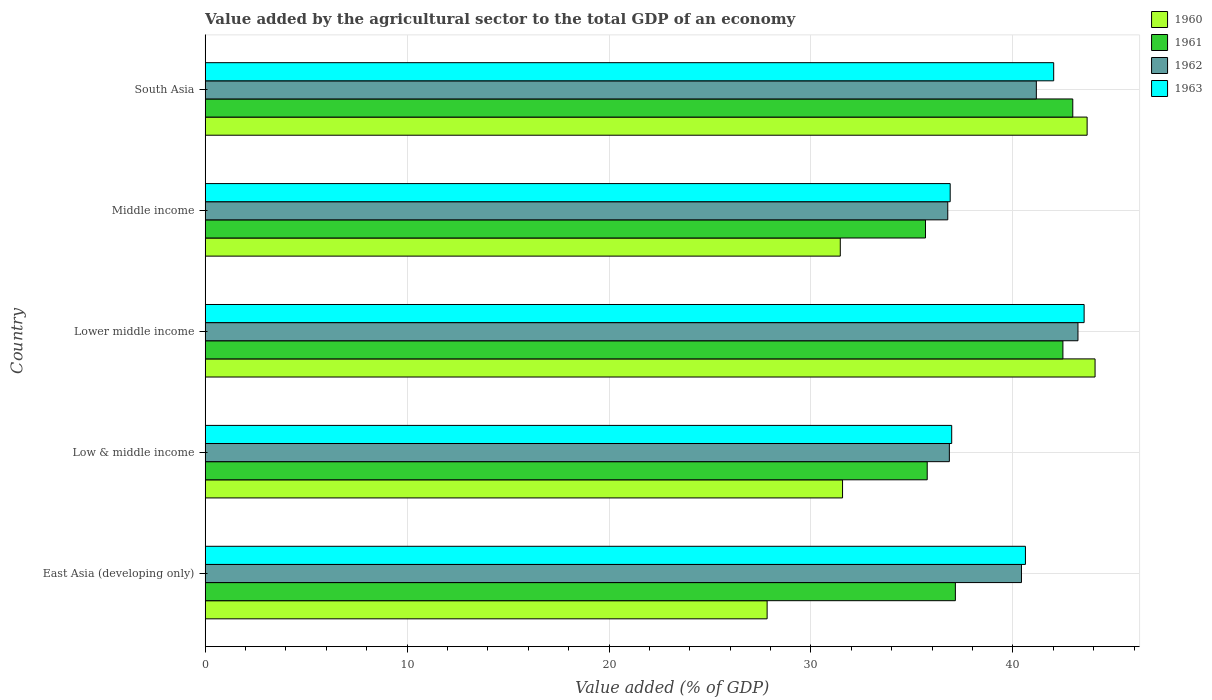How many different coloured bars are there?
Make the answer very short. 4. Are the number of bars per tick equal to the number of legend labels?
Your answer should be very brief. Yes. Are the number of bars on each tick of the Y-axis equal?
Your response must be concise. Yes. How many bars are there on the 1st tick from the top?
Offer a terse response. 4. How many bars are there on the 1st tick from the bottom?
Make the answer very short. 4. What is the label of the 3rd group of bars from the top?
Keep it short and to the point. Lower middle income. What is the value added by the agricultural sector to the total GDP in 1963 in Lower middle income?
Your response must be concise. 43.53. Across all countries, what is the maximum value added by the agricultural sector to the total GDP in 1962?
Offer a terse response. 43.22. Across all countries, what is the minimum value added by the agricultural sector to the total GDP in 1961?
Keep it short and to the point. 35.67. In which country was the value added by the agricultural sector to the total GDP in 1963 maximum?
Keep it short and to the point. Lower middle income. In which country was the value added by the agricultural sector to the total GDP in 1960 minimum?
Ensure brevity in your answer.  East Asia (developing only). What is the total value added by the agricultural sector to the total GDP in 1961 in the graph?
Your response must be concise. 194.02. What is the difference between the value added by the agricultural sector to the total GDP in 1963 in Low & middle income and that in Lower middle income?
Provide a short and direct response. -6.56. What is the difference between the value added by the agricultural sector to the total GDP in 1960 in Middle income and the value added by the agricultural sector to the total GDP in 1961 in Low & middle income?
Make the answer very short. -4.31. What is the average value added by the agricultural sector to the total GDP in 1960 per country?
Ensure brevity in your answer.  35.72. What is the difference between the value added by the agricultural sector to the total GDP in 1963 and value added by the agricultural sector to the total GDP in 1962 in Middle income?
Offer a very short reply. 0.12. In how many countries, is the value added by the agricultural sector to the total GDP in 1963 greater than 24 %?
Offer a very short reply. 5. What is the ratio of the value added by the agricultural sector to the total GDP in 1960 in East Asia (developing only) to that in South Asia?
Make the answer very short. 0.64. Is the difference between the value added by the agricultural sector to the total GDP in 1963 in East Asia (developing only) and Low & middle income greater than the difference between the value added by the agricultural sector to the total GDP in 1962 in East Asia (developing only) and Low & middle income?
Your answer should be very brief. Yes. What is the difference between the highest and the second highest value added by the agricultural sector to the total GDP in 1962?
Your answer should be very brief. 2.06. What is the difference between the highest and the lowest value added by the agricultural sector to the total GDP in 1962?
Your answer should be compact. 6.45. In how many countries, is the value added by the agricultural sector to the total GDP in 1962 greater than the average value added by the agricultural sector to the total GDP in 1962 taken over all countries?
Your answer should be compact. 3. Is the sum of the value added by the agricultural sector to the total GDP in 1960 in Low & middle income and South Asia greater than the maximum value added by the agricultural sector to the total GDP in 1963 across all countries?
Give a very brief answer. Yes. How many countries are there in the graph?
Offer a very short reply. 5. What is the difference between two consecutive major ticks on the X-axis?
Make the answer very short. 10. Are the values on the major ticks of X-axis written in scientific E-notation?
Provide a succinct answer. No. Does the graph contain any zero values?
Ensure brevity in your answer.  No. How are the legend labels stacked?
Offer a terse response. Vertical. What is the title of the graph?
Your response must be concise. Value added by the agricultural sector to the total GDP of an economy. What is the label or title of the X-axis?
Your answer should be compact. Value added (% of GDP). What is the label or title of the Y-axis?
Your answer should be compact. Country. What is the Value added (% of GDP) of 1960 in East Asia (developing only)?
Offer a very short reply. 27.83. What is the Value added (% of GDP) in 1961 in East Asia (developing only)?
Your answer should be very brief. 37.15. What is the Value added (% of GDP) of 1962 in East Asia (developing only)?
Ensure brevity in your answer.  40.42. What is the Value added (% of GDP) of 1963 in East Asia (developing only)?
Your answer should be very brief. 40.62. What is the Value added (% of GDP) of 1960 in Low & middle income?
Provide a succinct answer. 31.56. What is the Value added (% of GDP) of 1961 in Low & middle income?
Offer a terse response. 35.76. What is the Value added (% of GDP) in 1962 in Low & middle income?
Provide a short and direct response. 36.85. What is the Value added (% of GDP) in 1963 in Low & middle income?
Your answer should be compact. 36.97. What is the Value added (% of GDP) in 1960 in Lower middle income?
Your response must be concise. 44.07. What is the Value added (% of GDP) in 1961 in Lower middle income?
Ensure brevity in your answer.  42.48. What is the Value added (% of GDP) of 1962 in Lower middle income?
Your response must be concise. 43.22. What is the Value added (% of GDP) in 1963 in Lower middle income?
Keep it short and to the point. 43.53. What is the Value added (% of GDP) of 1960 in Middle income?
Your response must be concise. 31.45. What is the Value added (% of GDP) of 1961 in Middle income?
Give a very brief answer. 35.67. What is the Value added (% of GDP) of 1962 in Middle income?
Provide a succinct answer. 36.77. What is the Value added (% of GDP) of 1963 in Middle income?
Ensure brevity in your answer.  36.89. What is the Value added (% of GDP) of 1960 in South Asia?
Offer a terse response. 43.68. What is the Value added (% of GDP) of 1961 in South Asia?
Offer a terse response. 42.96. What is the Value added (% of GDP) of 1962 in South Asia?
Your answer should be very brief. 41.16. What is the Value added (% of GDP) in 1963 in South Asia?
Give a very brief answer. 42.02. Across all countries, what is the maximum Value added (% of GDP) in 1960?
Your answer should be compact. 44.07. Across all countries, what is the maximum Value added (% of GDP) of 1961?
Offer a very short reply. 42.96. Across all countries, what is the maximum Value added (% of GDP) of 1962?
Provide a succinct answer. 43.22. Across all countries, what is the maximum Value added (% of GDP) of 1963?
Provide a succinct answer. 43.53. Across all countries, what is the minimum Value added (% of GDP) in 1960?
Keep it short and to the point. 27.83. Across all countries, what is the minimum Value added (% of GDP) of 1961?
Ensure brevity in your answer.  35.67. Across all countries, what is the minimum Value added (% of GDP) in 1962?
Offer a very short reply. 36.77. Across all countries, what is the minimum Value added (% of GDP) of 1963?
Provide a short and direct response. 36.89. What is the total Value added (% of GDP) of 1960 in the graph?
Your answer should be compact. 178.59. What is the total Value added (% of GDP) in 1961 in the graph?
Ensure brevity in your answer.  194.02. What is the total Value added (% of GDP) of 1962 in the graph?
Provide a short and direct response. 198.43. What is the total Value added (% of GDP) in 1963 in the graph?
Provide a succinct answer. 200.03. What is the difference between the Value added (% of GDP) of 1960 in East Asia (developing only) and that in Low & middle income?
Your answer should be very brief. -3.74. What is the difference between the Value added (% of GDP) in 1961 in East Asia (developing only) and that in Low & middle income?
Make the answer very short. 1.39. What is the difference between the Value added (% of GDP) of 1962 in East Asia (developing only) and that in Low & middle income?
Keep it short and to the point. 3.57. What is the difference between the Value added (% of GDP) of 1963 in East Asia (developing only) and that in Low & middle income?
Your response must be concise. 3.65. What is the difference between the Value added (% of GDP) in 1960 in East Asia (developing only) and that in Lower middle income?
Your response must be concise. -16.24. What is the difference between the Value added (% of GDP) in 1961 in East Asia (developing only) and that in Lower middle income?
Provide a succinct answer. -5.33. What is the difference between the Value added (% of GDP) in 1962 in East Asia (developing only) and that in Lower middle income?
Your answer should be very brief. -2.8. What is the difference between the Value added (% of GDP) in 1963 in East Asia (developing only) and that in Lower middle income?
Your answer should be compact. -2.91. What is the difference between the Value added (% of GDP) of 1960 in East Asia (developing only) and that in Middle income?
Provide a short and direct response. -3.62. What is the difference between the Value added (% of GDP) of 1961 in East Asia (developing only) and that in Middle income?
Offer a terse response. 1.48. What is the difference between the Value added (% of GDP) of 1962 in East Asia (developing only) and that in Middle income?
Your answer should be very brief. 3.65. What is the difference between the Value added (% of GDP) in 1963 in East Asia (developing only) and that in Middle income?
Your answer should be very brief. 3.73. What is the difference between the Value added (% of GDP) of 1960 in East Asia (developing only) and that in South Asia?
Provide a succinct answer. -15.85. What is the difference between the Value added (% of GDP) of 1961 in East Asia (developing only) and that in South Asia?
Your answer should be very brief. -5.81. What is the difference between the Value added (% of GDP) of 1962 in East Asia (developing only) and that in South Asia?
Ensure brevity in your answer.  -0.74. What is the difference between the Value added (% of GDP) in 1963 in East Asia (developing only) and that in South Asia?
Keep it short and to the point. -1.4. What is the difference between the Value added (% of GDP) in 1960 in Low & middle income and that in Lower middle income?
Your response must be concise. -12.51. What is the difference between the Value added (% of GDP) of 1961 in Low & middle income and that in Lower middle income?
Give a very brief answer. -6.72. What is the difference between the Value added (% of GDP) of 1962 in Low & middle income and that in Lower middle income?
Keep it short and to the point. -6.37. What is the difference between the Value added (% of GDP) in 1963 in Low & middle income and that in Lower middle income?
Provide a short and direct response. -6.56. What is the difference between the Value added (% of GDP) in 1960 in Low & middle income and that in Middle income?
Your response must be concise. 0.11. What is the difference between the Value added (% of GDP) in 1961 in Low & middle income and that in Middle income?
Give a very brief answer. 0.09. What is the difference between the Value added (% of GDP) in 1962 in Low & middle income and that in Middle income?
Provide a succinct answer. 0.08. What is the difference between the Value added (% of GDP) in 1963 in Low & middle income and that in Middle income?
Your answer should be very brief. 0.07. What is the difference between the Value added (% of GDP) of 1960 in Low & middle income and that in South Asia?
Your answer should be very brief. -12.11. What is the difference between the Value added (% of GDP) in 1961 in Low & middle income and that in South Asia?
Keep it short and to the point. -7.21. What is the difference between the Value added (% of GDP) in 1962 in Low & middle income and that in South Asia?
Offer a terse response. -4.31. What is the difference between the Value added (% of GDP) of 1963 in Low & middle income and that in South Asia?
Offer a terse response. -5.05. What is the difference between the Value added (% of GDP) in 1960 in Lower middle income and that in Middle income?
Ensure brevity in your answer.  12.62. What is the difference between the Value added (% of GDP) of 1961 in Lower middle income and that in Middle income?
Offer a very short reply. 6.81. What is the difference between the Value added (% of GDP) in 1962 in Lower middle income and that in Middle income?
Make the answer very short. 6.45. What is the difference between the Value added (% of GDP) of 1963 in Lower middle income and that in Middle income?
Make the answer very short. 6.63. What is the difference between the Value added (% of GDP) of 1960 in Lower middle income and that in South Asia?
Your answer should be compact. 0.39. What is the difference between the Value added (% of GDP) of 1961 in Lower middle income and that in South Asia?
Your answer should be compact. -0.49. What is the difference between the Value added (% of GDP) in 1962 in Lower middle income and that in South Asia?
Keep it short and to the point. 2.06. What is the difference between the Value added (% of GDP) of 1963 in Lower middle income and that in South Asia?
Your answer should be very brief. 1.51. What is the difference between the Value added (% of GDP) of 1960 in Middle income and that in South Asia?
Your response must be concise. -12.22. What is the difference between the Value added (% of GDP) of 1961 in Middle income and that in South Asia?
Keep it short and to the point. -7.29. What is the difference between the Value added (% of GDP) of 1962 in Middle income and that in South Asia?
Your answer should be compact. -4.39. What is the difference between the Value added (% of GDP) in 1963 in Middle income and that in South Asia?
Offer a terse response. -5.13. What is the difference between the Value added (% of GDP) in 1960 in East Asia (developing only) and the Value added (% of GDP) in 1961 in Low & middle income?
Provide a short and direct response. -7.93. What is the difference between the Value added (% of GDP) in 1960 in East Asia (developing only) and the Value added (% of GDP) in 1962 in Low & middle income?
Offer a very short reply. -9.02. What is the difference between the Value added (% of GDP) in 1960 in East Asia (developing only) and the Value added (% of GDP) in 1963 in Low & middle income?
Give a very brief answer. -9.14. What is the difference between the Value added (% of GDP) of 1961 in East Asia (developing only) and the Value added (% of GDP) of 1962 in Low & middle income?
Your answer should be very brief. 0.3. What is the difference between the Value added (% of GDP) of 1961 in East Asia (developing only) and the Value added (% of GDP) of 1963 in Low & middle income?
Make the answer very short. 0.18. What is the difference between the Value added (% of GDP) of 1962 in East Asia (developing only) and the Value added (% of GDP) of 1963 in Low & middle income?
Give a very brief answer. 3.46. What is the difference between the Value added (% of GDP) of 1960 in East Asia (developing only) and the Value added (% of GDP) of 1961 in Lower middle income?
Provide a succinct answer. -14.65. What is the difference between the Value added (% of GDP) of 1960 in East Asia (developing only) and the Value added (% of GDP) of 1962 in Lower middle income?
Ensure brevity in your answer.  -15.39. What is the difference between the Value added (% of GDP) in 1960 in East Asia (developing only) and the Value added (% of GDP) in 1963 in Lower middle income?
Give a very brief answer. -15.7. What is the difference between the Value added (% of GDP) in 1961 in East Asia (developing only) and the Value added (% of GDP) in 1962 in Lower middle income?
Make the answer very short. -6.07. What is the difference between the Value added (% of GDP) of 1961 in East Asia (developing only) and the Value added (% of GDP) of 1963 in Lower middle income?
Offer a terse response. -6.38. What is the difference between the Value added (% of GDP) of 1962 in East Asia (developing only) and the Value added (% of GDP) of 1963 in Lower middle income?
Make the answer very short. -3.1. What is the difference between the Value added (% of GDP) in 1960 in East Asia (developing only) and the Value added (% of GDP) in 1961 in Middle income?
Provide a succinct answer. -7.84. What is the difference between the Value added (% of GDP) in 1960 in East Asia (developing only) and the Value added (% of GDP) in 1962 in Middle income?
Provide a short and direct response. -8.95. What is the difference between the Value added (% of GDP) in 1960 in East Asia (developing only) and the Value added (% of GDP) in 1963 in Middle income?
Provide a succinct answer. -9.07. What is the difference between the Value added (% of GDP) in 1961 in East Asia (developing only) and the Value added (% of GDP) in 1962 in Middle income?
Your answer should be compact. 0.38. What is the difference between the Value added (% of GDP) in 1961 in East Asia (developing only) and the Value added (% of GDP) in 1963 in Middle income?
Provide a succinct answer. 0.26. What is the difference between the Value added (% of GDP) in 1962 in East Asia (developing only) and the Value added (% of GDP) in 1963 in Middle income?
Make the answer very short. 3.53. What is the difference between the Value added (% of GDP) of 1960 in East Asia (developing only) and the Value added (% of GDP) of 1961 in South Asia?
Give a very brief answer. -15.14. What is the difference between the Value added (% of GDP) of 1960 in East Asia (developing only) and the Value added (% of GDP) of 1962 in South Asia?
Offer a very short reply. -13.33. What is the difference between the Value added (% of GDP) in 1960 in East Asia (developing only) and the Value added (% of GDP) in 1963 in South Asia?
Make the answer very short. -14.19. What is the difference between the Value added (% of GDP) in 1961 in East Asia (developing only) and the Value added (% of GDP) in 1962 in South Asia?
Provide a succinct answer. -4.01. What is the difference between the Value added (% of GDP) of 1961 in East Asia (developing only) and the Value added (% of GDP) of 1963 in South Asia?
Ensure brevity in your answer.  -4.87. What is the difference between the Value added (% of GDP) of 1962 in East Asia (developing only) and the Value added (% of GDP) of 1963 in South Asia?
Keep it short and to the point. -1.6. What is the difference between the Value added (% of GDP) of 1960 in Low & middle income and the Value added (% of GDP) of 1961 in Lower middle income?
Your answer should be very brief. -10.91. What is the difference between the Value added (% of GDP) of 1960 in Low & middle income and the Value added (% of GDP) of 1962 in Lower middle income?
Make the answer very short. -11.66. What is the difference between the Value added (% of GDP) of 1960 in Low & middle income and the Value added (% of GDP) of 1963 in Lower middle income?
Your answer should be compact. -11.96. What is the difference between the Value added (% of GDP) of 1961 in Low & middle income and the Value added (% of GDP) of 1962 in Lower middle income?
Provide a short and direct response. -7.47. What is the difference between the Value added (% of GDP) in 1961 in Low & middle income and the Value added (% of GDP) in 1963 in Lower middle income?
Your response must be concise. -7.77. What is the difference between the Value added (% of GDP) in 1962 in Low & middle income and the Value added (% of GDP) in 1963 in Lower middle income?
Ensure brevity in your answer.  -6.67. What is the difference between the Value added (% of GDP) in 1960 in Low & middle income and the Value added (% of GDP) in 1961 in Middle income?
Provide a succinct answer. -4.11. What is the difference between the Value added (% of GDP) in 1960 in Low & middle income and the Value added (% of GDP) in 1962 in Middle income?
Your response must be concise. -5.21. What is the difference between the Value added (% of GDP) of 1960 in Low & middle income and the Value added (% of GDP) of 1963 in Middle income?
Offer a terse response. -5.33. What is the difference between the Value added (% of GDP) of 1961 in Low & middle income and the Value added (% of GDP) of 1962 in Middle income?
Offer a very short reply. -1.02. What is the difference between the Value added (% of GDP) in 1961 in Low & middle income and the Value added (% of GDP) in 1963 in Middle income?
Keep it short and to the point. -1.14. What is the difference between the Value added (% of GDP) of 1962 in Low & middle income and the Value added (% of GDP) of 1963 in Middle income?
Your answer should be very brief. -0.04. What is the difference between the Value added (% of GDP) of 1960 in Low & middle income and the Value added (% of GDP) of 1961 in South Asia?
Provide a short and direct response. -11.4. What is the difference between the Value added (% of GDP) of 1960 in Low & middle income and the Value added (% of GDP) of 1962 in South Asia?
Your answer should be very brief. -9.6. What is the difference between the Value added (% of GDP) of 1960 in Low & middle income and the Value added (% of GDP) of 1963 in South Asia?
Provide a short and direct response. -10.46. What is the difference between the Value added (% of GDP) in 1961 in Low & middle income and the Value added (% of GDP) in 1962 in South Asia?
Offer a very short reply. -5.4. What is the difference between the Value added (% of GDP) of 1961 in Low & middle income and the Value added (% of GDP) of 1963 in South Asia?
Offer a very short reply. -6.26. What is the difference between the Value added (% of GDP) of 1962 in Low & middle income and the Value added (% of GDP) of 1963 in South Asia?
Offer a terse response. -5.17. What is the difference between the Value added (% of GDP) in 1960 in Lower middle income and the Value added (% of GDP) in 1961 in Middle income?
Offer a very short reply. 8.4. What is the difference between the Value added (% of GDP) of 1960 in Lower middle income and the Value added (% of GDP) of 1962 in Middle income?
Ensure brevity in your answer.  7.29. What is the difference between the Value added (% of GDP) in 1960 in Lower middle income and the Value added (% of GDP) in 1963 in Middle income?
Your answer should be very brief. 7.17. What is the difference between the Value added (% of GDP) in 1961 in Lower middle income and the Value added (% of GDP) in 1962 in Middle income?
Provide a succinct answer. 5.7. What is the difference between the Value added (% of GDP) of 1961 in Lower middle income and the Value added (% of GDP) of 1963 in Middle income?
Offer a very short reply. 5.58. What is the difference between the Value added (% of GDP) of 1962 in Lower middle income and the Value added (% of GDP) of 1963 in Middle income?
Give a very brief answer. 6.33. What is the difference between the Value added (% of GDP) in 1960 in Lower middle income and the Value added (% of GDP) in 1961 in South Asia?
Your response must be concise. 1.1. What is the difference between the Value added (% of GDP) of 1960 in Lower middle income and the Value added (% of GDP) of 1962 in South Asia?
Your response must be concise. 2.91. What is the difference between the Value added (% of GDP) of 1960 in Lower middle income and the Value added (% of GDP) of 1963 in South Asia?
Your answer should be compact. 2.05. What is the difference between the Value added (% of GDP) of 1961 in Lower middle income and the Value added (% of GDP) of 1962 in South Asia?
Keep it short and to the point. 1.32. What is the difference between the Value added (% of GDP) of 1961 in Lower middle income and the Value added (% of GDP) of 1963 in South Asia?
Offer a very short reply. 0.46. What is the difference between the Value added (% of GDP) in 1962 in Lower middle income and the Value added (% of GDP) in 1963 in South Asia?
Your response must be concise. 1.2. What is the difference between the Value added (% of GDP) of 1960 in Middle income and the Value added (% of GDP) of 1961 in South Asia?
Your answer should be very brief. -11.51. What is the difference between the Value added (% of GDP) in 1960 in Middle income and the Value added (% of GDP) in 1962 in South Asia?
Give a very brief answer. -9.71. What is the difference between the Value added (% of GDP) of 1960 in Middle income and the Value added (% of GDP) of 1963 in South Asia?
Offer a terse response. -10.57. What is the difference between the Value added (% of GDP) of 1961 in Middle income and the Value added (% of GDP) of 1962 in South Asia?
Your answer should be very brief. -5.49. What is the difference between the Value added (% of GDP) in 1961 in Middle income and the Value added (% of GDP) in 1963 in South Asia?
Your response must be concise. -6.35. What is the difference between the Value added (% of GDP) in 1962 in Middle income and the Value added (% of GDP) in 1963 in South Asia?
Give a very brief answer. -5.25. What is the average Value added (% of GDP) in 1960 per country?
Your answer should be compact. 35.72. What is the average Value added (% of GDP) in 1961 per country?
Offer a very short reply. 38.8. What is the average Value added (% of GDP) in 1962 per country?
Offer a terse response. 39.69. What is the average Value added (% of GDP) in 1963 per country?
Give a very brief answer. 40.01. What is the difference between the Value added (% of GDP) of 1960 and Value added (% of GDP) of 1961 in East Asia (developing only)?
Your response must be concise. -9.32. What is the difference between the Value added (% of GDP) of 1960 and Value added (% of GDP) of 1962 in East Asia (developing only)?
Give a very brief answer. -12.6. What is the difference between the Value added (% of GDP) in 1960 and Value added (% of GDP) in 1963 in East Asia (developing only)?
Provide a succinct answer. -12.79. What is the difference between the Value added (% of GDP) in 1961 and Value added (% of GDP) in 1962 in East Asia (developing only)?
Your answer should be compact. -3.27. What is the difference between the Value added (% of GDP) in 1961 and Value added (% of GDP) in 1963 in East Asia (developing only)?
Offer a terse response. -3.47. What is the difference between the Value added (% of GDP) in 1962 and Value added (% of GDP) in 1963 in East Asia (developing only)?
Your response must be concise. -0.2. What is the difference between the Value added (% of GDP) of 1960 and Value added (% of GDP) of 1961 in Low & middle income?
Ensure brevity in your answer.  -4.19. What is the difference between the Value added (% of GDP) in 1960 and Value added (% of GDP) in 1962 in Low & middle income?
Give a very brief answer. -5.29. What is the difference between the Value added (% of GDP) in 1960 and Value added (% of GDP) in 1963 in Low & middle income?
Your response must be concise. -5.41. What is the difference between the Value added (% of GDP) in 1961 and Value added (% of GDP) in 1962 in Low & middle income?
Give a very brief answer. -1.1. What is the difference between the Value added (% of GDP) in 1961 and Value added (% of GDP) in 1963 in Low & middle income?
Provide a succinct answer. -1.21. What is the difference between the Value added (% of GDP) in 1962 and Value added (% of GDP) in 1963 in Low & middle income?
Give a very brief answer. -0.12. What is the difference between the Value added (% of GDP) in 1960 and Value added (% of GDP) in 1961 in Lower middle income?
Ensure brevity in your answer.  1.59. What is the difference between the Value added (% of GDP) of 1960 and Value added (% of GDP) of 1962 in Lower middle income?
Your response must be concise. 0.85. What is the difference between the Value added (% of GDP) in 1960 and Value added (% of GDP) in 1963 in Lower middle income?
Make the answer very short. 0.54. What is the difference between the Value added (% of GDP) in 1961 and Value added (% of GDP) in 1962 in Lower middle income?
Give a very brief answer. -0.75. What is the difference between the Value added (% of GDP) of 1961 and Value added (% of GDP) of 1963 in Lower middle income?
Ensure brevity in your answer.  -1.05. What is the difference between the Value added (% of GDP) in 1962 and Value added (% of GDP) in 1963 in Lower middle income?
Keep it short and to the point. -0.3. What is the difference between the Value added (% of GDP) of 1960 and Value added (% of GDP) of 1961 in Middle income?
Your answer should be compact. -4.22. What is the difference between the Value added (% of GDP) of 1960 and Value added (% of GDP) of 1962 in Middle income?
Provide a succinct answer. -5.32. What is the difference between the Value added (% of GDP) of 1960 and Value added (% of GDP) of 1963 in Middle income?
Provide a short and direct response. -5.44. What is the difference between the Value added (% of GDP) in 1961 and Value added (% of GDP) in 1962 in Middle income?
Ensure brevity in your answer.  -1.1. What is the difference between the Value added (% of GDP) in 1961 and Value added (% of GDP) in 1963 in Middle income?
Offer a terse response. -1.22. What is the difference between the Value added (% of GDP) in 1962 and Value added (% of GDP) in 1963 in Middle income?
Keep it short and to the point. -0.12. What is the difference between the Value added (% of GDP) of 1960 and Value added (% of GDP) of 1961 in South Asia?
Keep it short and to the point. 0.71. What is the difference between the Value added (% of GDP) in 1960 and Value added (% of GDP) in 1962 in South Asia?
Make the answer very short. 2.52. What is the difference between the Value added (% of GDP) in 1960 and Value added (% of GDP) in 1963 in South Asia?
Keep it short and to the point. 1.66. What is the difference between the Value added (% of GDP) in 1961 and Value added (% of GDP) in 1962 in South Asia?
Make the answer very short. 1.8. What is the difference between the Value added (% of GDP) in 1961 and Value added (% of GDP) in 1963 in South Asia?
Keep it short and to the point. 0.95. What is the difference between the Value added (% of GDP) of 1962 and Value added (% of GDP) of 1963 in South Asia?
Keep it short and to the point. -0.86. What is the ratio of the Value added (% of GDP) in 1960 in East Asia (developing only) to that in Low & middle income?
Provide a short and direct response. 0.88. What is the ratio of the Value added (% of GDP) in 1961 in East Asia (developing only) to that in Low & middle income?
Keep it short and to the point. 1.04. What is the ratio of the Value added (% of GDP) in 1962 in East Asia (developing only) to that in Low & middle income?
Give a very brief answer. 1.1. What is the ratio of the Value added (% of GDP) of 1963 in East Asia (developing only) to that in Low & middle income?
Your response must be concise. 1.1. What is the ratio of the Value added (% of GDP) in 1960 in East Asia (developing only) to that in Lower middle income?
Offer a very short reply. 0.63. What is the ratio of the Value added (% of GDP) in 1961 in East Asia (developing only) to that in Lower middle income?
Your answer should be very brief. 0.87. What is the ratio of the Value added (% of GDP) of 1962 in East Asia (developing only) to that in Lower middle income?
Provide a succinct answer. 0.94. What is the ratio of the Value added (% of GDP) in 1963 in East Asia (developing only) to that in Lower middle income?
Your answer should be very brief. 0.93. What is the ratio of the Value added (% of GDP) in 1960 in East Asia (developing only) to that in Middle income?
Provide a short and direct response. 0.88. What is the ratio of the Value added (% of GDP) of 1961 in East Asia (developing only) to that in Middle income?
Offer a terse response. 1.04. What is the ratio of the Value added (% of GDP) of 1962 in East Asia (developing only) to that in Middle income?
Provide a succinct answer. 1.1. What is the ratio of the Value added (% of GDP) in 1963 in East Asia (developing only) to that in Middle income?
Keep it short and to the point. 1.1. What is the ratio of the Value added (% of GDP) in 1960 in East Asia (developing only) to that in South Asia?
Make the answer very short. 0.64. What is the ratio of the Value added (% of GDP) in 1961 in East Asia (developing only) to that in South Asia?
Your response must be concise. 0.86. What is the ratio of the Value added (% of GDP) of 1962 in East Asia (developing only) to that in South Asia?
Give a very brief answer. 0.98. What is the ratio of the Value added (% of GDP) of 1963 in East Asia (developing only) to that in South Asia?
Offer a very short reply. 0.97. What is the ratio of the Value added (% of GDP) in 1960 in Low & middle income to that in Lower middle income?
Offer a terse response. 0.72. What is the ratio of the Value added (% of GDP) of 1961 in Low & middle income to that in Lower middle income?
Your answer should be very brief. 0.84. What is the ratio of the Value added (% of GDP) of 1962 in Low & middle income to that in Lower middle income?
Give a very brief answer. 0.85. What is the ratio of the Value added (% of GDP) in 1963 in Low & middle income to that in Lower middle income?
Keep it short and to the point. 0.85. What is the ratio of the Value added (% of GDP) of 1960 in Low & middle income to that in Middle income?
Ensure brevity in your answer.  1. What is the ratio of the Value added (% of GDP) in 1961 in Low & middle income to that in Middle income?
Offer a very short reply. 1. What is the ratio of the Value added (% of GDP) in 1960 in Low & middle income to that in South Asia?
Give a very brief answer. 0.72. What is the ratio of the Value added (% of GDP) of 1961 in Low & middle income to that in South Asia?
Keep it short and to the point. 0.83. What is the ratio of the Value added (% of GDP) in 1962 in Low & middle income to that in South Asia?
Offer a very short reply. 0.9. What is the ratio of the Value added (% of GDP) of 1963 in Low & middle income to that in South Asia?
Give a very brief answer. 0.88. What is the ratio of the Value added (% of GDP) in 1960 in Lower middle income to that in Middle income?
Your answer should be very brief. 1.4. What is the ratio of the Value added (% of GDP) in 1961 in Lower middle income to that in Middle income?
Offer a terse response. 1.19. What is the ratio of the Value added (% of GDP) of 1962 in Lower middle income to that in Middle income?
Give a very brief answer. 1.18. What is the ratio of the Value added (% of GDP) of 1963 in Lower middle income to that in Middle income?
Provide a succinct answer. 1.18. What is the ratio of the Value added (% of GDP) of 1960 in Lower middle income to that in South Asia?
Provide a succinct answer. 1.01. What is the ratio of the Value added (% of GDP) in 1962 in Lower middle income to that in South Asia?
Your answer should be very brief. 1.05. What is the ratio of the Value added (% of GDP) of 1963 in Lower middle income to that in South Asia?
Provide a short and direct response. 1.04. What is the ratio of the Value added (% of GDP) in 1960 in Middle income to that in South Asia?
Provide a short and direct response. 0.72. What is the ratio of the Value added (% of GDP) of 1961 in Middle income to that in South Asia?
Your answer should be very brief. 0.83. What is the ratio of the Value added (% of GDP) in 1962 in Middle income to that in South Asia?
Make the answer very short. 0.89. What is the ratio of the Value added (% of GDP) of 1963 in Middle income to that in South Asia?
Keep it short and to the point. 0.88. What is the difference between the highest and the second highest Value added (% of GDP) in 1960?
Your response must be concise. 0.39. What is the difference between the highest and the second highest Value added (% of GDP) in 1961?
Provide a short and direct response. 0.49. What is the difference between the highest and the second highest Value added (% of GDP) in 1962?
Offer a very short reply. 2.06. What is the difference between the highest and the second highest Value added (% of GDP) in 1963?
Offer a terse response. 1.51. What is the difference between the highest and the lowest Value added (% of GDP) of 1960?
Provide a succinct answer. 16.24. What is the difference between the highest and the lowest Value added (% of GDP) in 1961?
Make the answer very short. 7.29. What is the difference between the highest and the lowest Value added (% of GDP) in 1962?
Give a very brief answer. 6.45. What is the difference between the highest and the lowest Value added (% of GDP) of 1963?
Give a very brief answer. 6.63. 